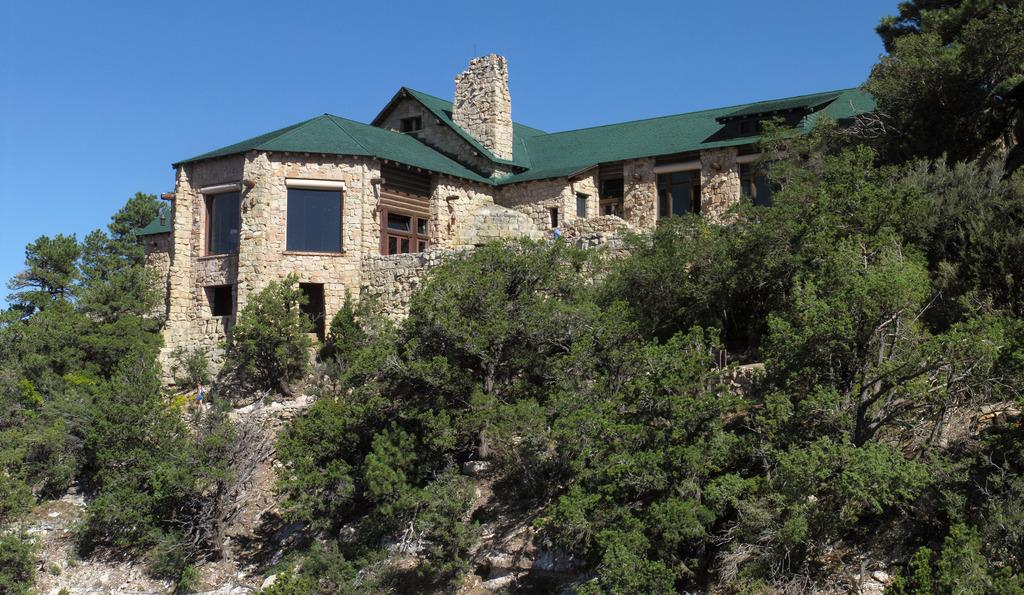What type of vegetation can be seen in the image? There are trees in the image. What type of structure is present in the image? There is a house in the image. What is visible in the background of the image? The sky is visible in the background of the image. Can you see a goat playing volleyball under an umbrella in the image? No, there is no goat, volleyball, or umbrella present in the image. 